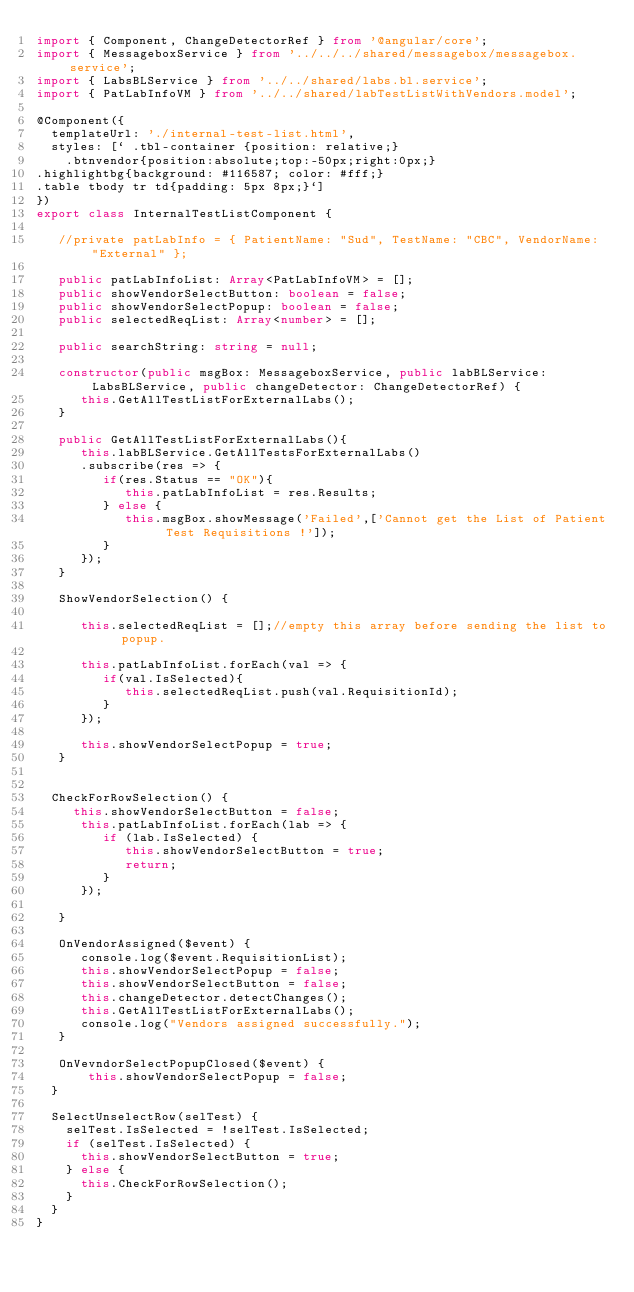Convert code to text. <code><loc_0><loc_0><loc_500><loc_500><_TypeScript_>import { Component, ChangeDetectorRef } from '@angular/core';
import { MessageboxService } from '../../../shared/messagebox/messagebox.service';
import { LabsBLService } from '../../shared/labs.bl.service';
import { PatLabInfoVM } from '../../shared/labTestListWithVendors.model';

@Component({
  templateUrl: './internal-test-list.html',
  styles: [` .tbl-container {position: relative;}
    .btnvendor{position:absolute;top:-50px;right:0px;}
.highlightbg{background: #116587; color: #fff;}
.table tbody tr td{padding: 5px 8px;}`]
})
export class InternalTestListComponent {

   //private patLabInfo = { PatientName: "Sud", TestName: "CBC", VendorName: "External" };

   public patLabInfoList: Array<PatLabInfoVM> = [];
   public showVendorSelectButton: boolean = false;
   public showVendorSelectPopup: boolean = false;
   public selectedReqList: Array<number> = [];

   public searchString: string = null;

   constructor(public msgBox: MessageboxService, public labBLService: LabsBLService, public changeDetector: ChangeDetectorRef) {     
      this.GetAllTestListForExternalLabs();
   }

   public GetAllTestListForExternalLabs(){
      this.labBLService.GetAllTestsForExternalLabs()
      .subscribe(res => {
         if(res.Status == "OK"){
            this.patLabInfoList = res.Results;
         } else {
            this.msgBox.showMessage('Failed',['Cannot get the List of Patient Test Requisitions !']);
         }
      });      
   }

   ShowVendorSelection() {

      this.selectedReqList = [];//empty this array before sending the list to popup.

      this.patLabInfoList.forEach(val => {
         if(val.IsSelected){
            this.selectedReqList.push(val.RequisitionId);
         }
      });

      this.showVendorSelectPopup = true;
   }


  CheckForRowSelection() {
     this.showVendorSelectButton = false;
      this.patLabInfoList.forEach(lab => {
         if (lab.IsSelected) {
            this.showVendorSelectButton = true;
            return;
         }
      });

   }

   OnVendorAssigned($event) {
      console.log($event.RequisitionList);
      this.showVendorSelectPopup = false;
      this.showVendorSelectButton = false;
      this.changeDetector.detectChanges();
      this.GetAllTestListForExternalLabs();
      console.log("Vendors assigned successfully.");
   }

   OnVevndorSelectPopupClosed($event) {
       this.showVendorSelectPopup = false;
  }

  SelectUnselectRow(selTest) {
    selTest.IsSelected = !selTest.IsSelected;
    if (selTest.IsSelected) {
      this.showVendorSelectButton = true;
    } else {
      this.CheckForRowSelection();
    }
  }
}



</code> 